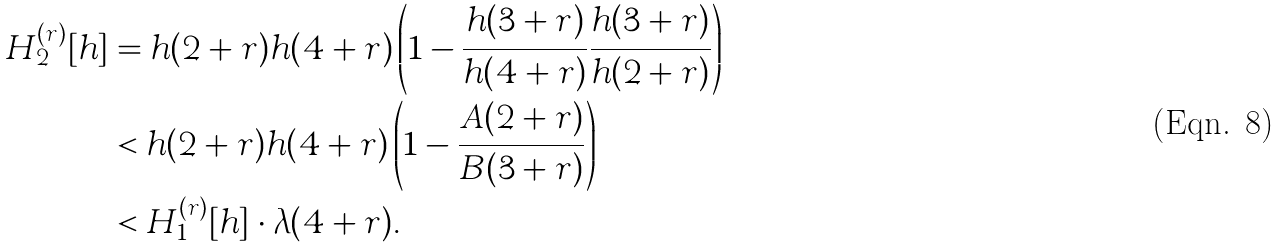<formula> <loc_0><loc_0><loc_500><loc_500>H _ { 2 } ^ { ( r ) } [ h ] & = h ( 2 + r ) h ( 4 + r ) \left ( 1 - \frac { h ( 3 + r ) } { h ( 4 + r ) } \frac { h ( 3 + r ) } { h ( 2 + r ) } \right ) \\ & < h ( 2 + r ) h ( 4 + r ) \left ( 1 - \frac { A ( 2 + r ) } { B ( 3 + r ) } \right ) \\ & < H _ { 1 } ^ { ( r ) } [ h ] \cdot \lambda ( 4 + r ) .</formula> 